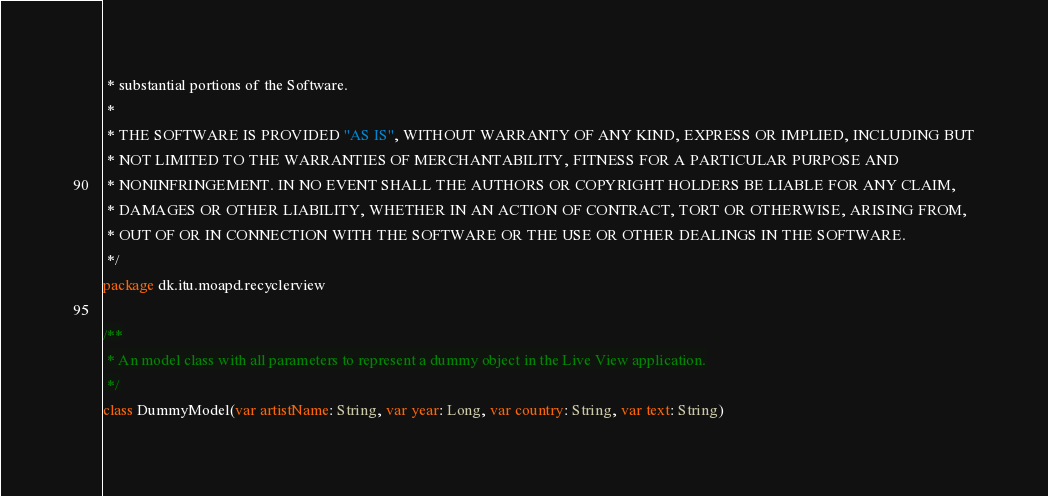Convert code to text. <code><loc_0><loc_0><loc_500><loc_500><_Kotlin_> * substantial portions of the Software.
 *
 * THE SOFTWARE IS PROVIDED "AS IS", WITHOUT WARRANTY OF ANY KIND, EXPRESS OR IMPLIED, INCLUDING BUT
 * NOT LIMITED TO THE WARRANTIES OF MERCHANTABILITY, FITNESS FOR A PARTICULAR PURPOSE AND
 * NONINFRINGEMENT. IN NO EVENT SHALL THE AUTHORS OR COPYRIGHT HOLDERS BE LIABLE FOR ANY CLAIM,
 * DAMAGES OR OTHER LIABILITY, WHETHER IN AN ACTION OF CONTRACT, TORT OR OTHERWISE, ARISING FROM,
 * OUT OF OR IN CONNECTION WITH THE SOFTWARE OR THE USE OR OTHER DEALINGS IN THE SOFTWARE.
 */
package dk.itu.moapd.recyclerview

/**
 * An model class with all parameters to represent a dummy object in the Live View application.
 */
class DummyModel(var artistName: String, var year: Long, var country: String, var text: String)
</code> 